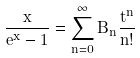<formula> <loc_0><loc_0><loc_500><loc_500>\frac { x } { e ^ { x } - 1 } = \sum _ { n = 0 } ^ { \infty } B _ { n } \frac { t ^ { n } } { n ! }</formula> 